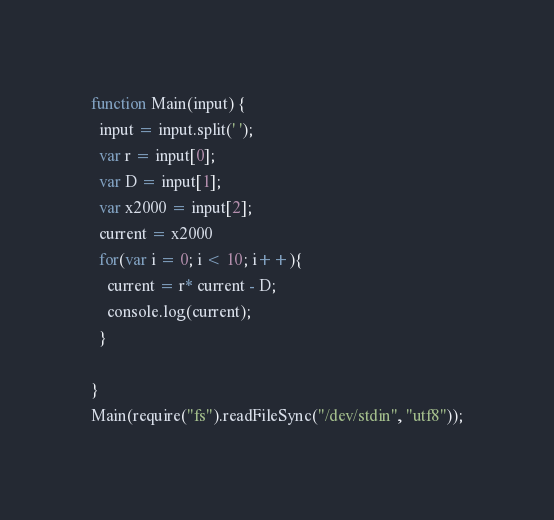<code> <loc_0><loc_0><loc_500><loc_500><_JavaScript_>function Main(input) {
  input = input.split(' ');
  var r = input[0];
  var D = input[1];
  var x2000 = input[2];
  current = x2000
  for(var i = 0; i < 10; i++){
    current = r* current - D;
    console.log(current);
  }
  
}
Main(require("fs").readFileSync("/dev/stdin", "utf8"));</code> 